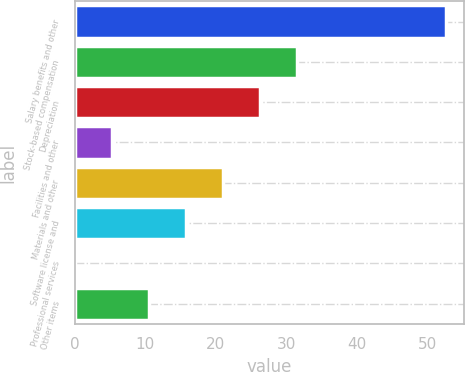Convert chart to OTSL. <chart><loc_0><loc_0><loc_500><loc_500><bar_chart><fcel>Salary benefits and other<fcel>Stock-based compensation<fcel>Depreciation<fcel>Facilities and other<fcel>Materials and other<fcel>Software license and<fcel>Professional services<fcel>Other items<nl><fcel>52.5<fcel>31.54<fcel>26.3<fcel>5.34<fcel>21.06<fcel>15.82<fcel>0.1<fcel>10.58<nl></chart> 